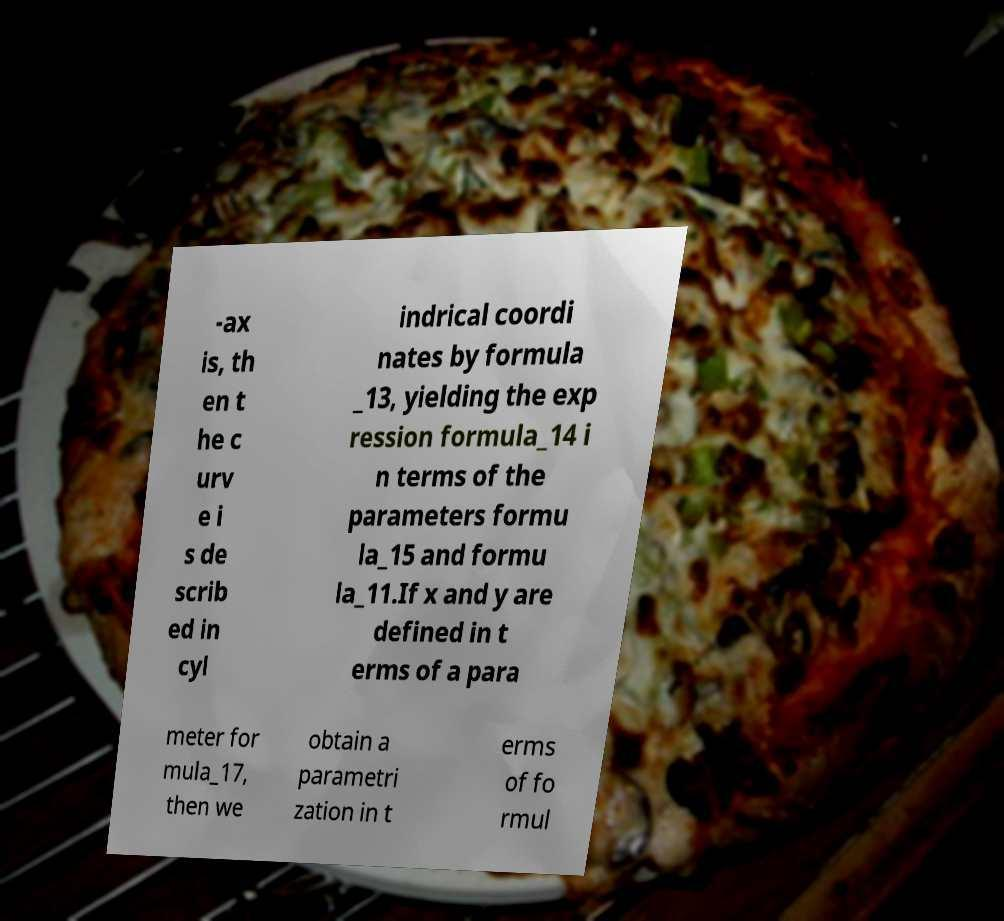For documentation purposes, I need the text within this image transcribed. Could you provide that? -ax is, th en t he c urv e i s de scrib ed in cyl indrical coordi nates by formula _13, yielding the exp ression formula_14 i n terms of the parameters formu la_15 and formu la_11.If x and y are defined in t erms of a para meter for mula_17, then we obtain a parametri zation in t erms of fo rmul 